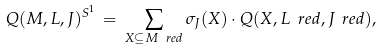Convert formula to latex. <formula><loc_0><loc_0><loc_500><loc_500>\label l { f o r m u l a - a - c } Q ( M , L , J ) ^ { S ^ { 1 } } \, = \, \sum _ { X \subseteq M _ { \ } r e d } \sigma _ { J } ( X ) \cdot Q ( X , L _ { \ } r e d , J _ { \ } r e d ) ,</formula> 